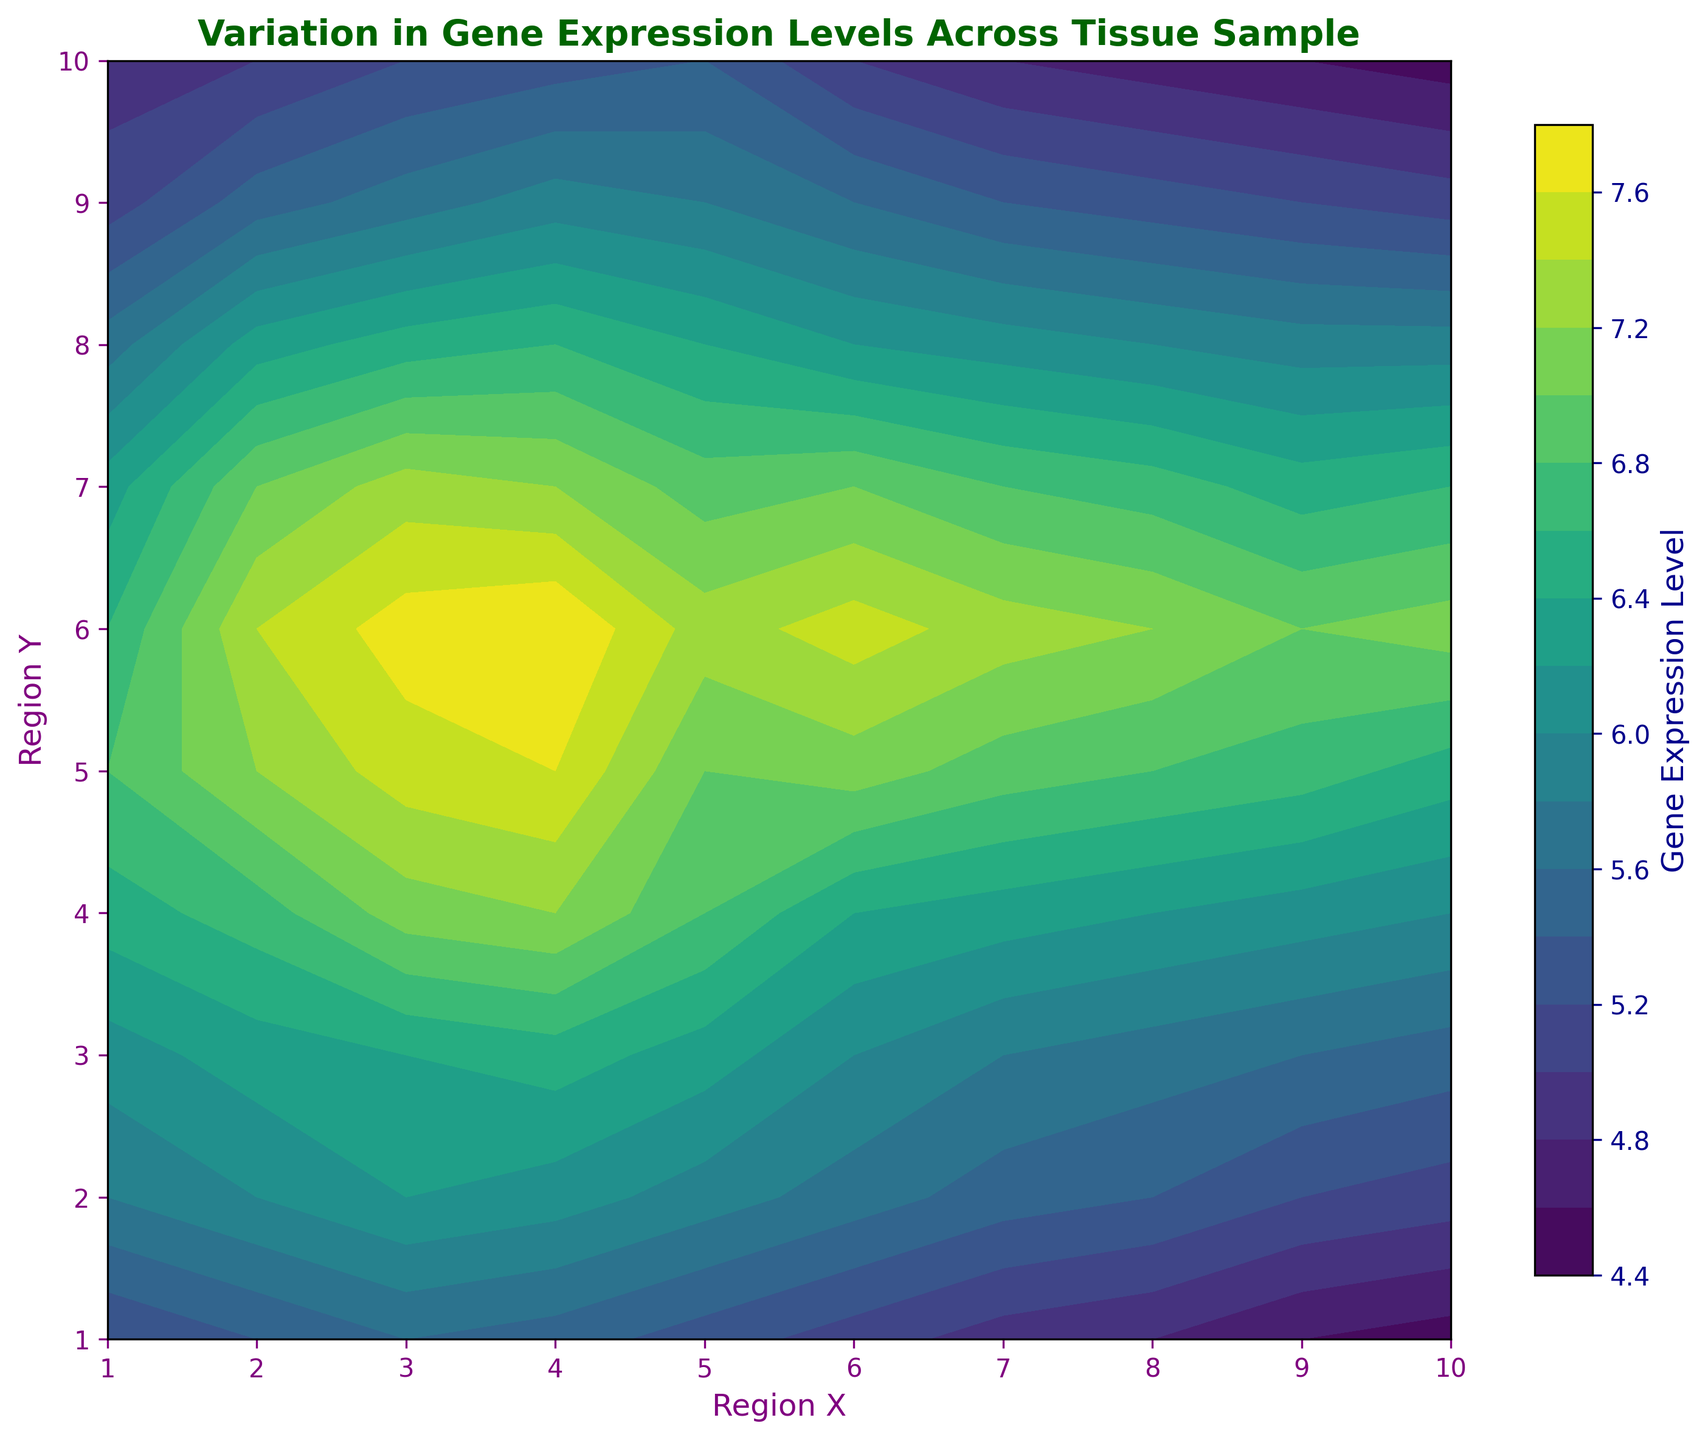What's the highest gene expression level in the tissue sample? Examine the color bar and locate the highest value represented. The highest level is observed as the deepest color presented in the contour plot, which aligns with approximately 7.8.
Answer: 7.8 In which regions do we observe the lowest values for gene expression? Identify the regions with the lightest colors on the plot. The lightest regions, along with reference to the color bar, indicate the lowest gene expression levels, which occur near (10,1) and (10,10).
Answer: (10,1) and (10,10) Which region has the highest variability in gene expression from top to bottom? Compare the vertical color transitions for each region. Region X=1 shows the highest color variation from top to bottom, indicating the most variability in gene expression from Y=1 to Y=10.
Answer: X=1 What is the range of gene expression levels in Region X=5? Identify the minimum and maximum values within X=5. Using color transitions and the color bar, the lowest value is approximately 5.3 and the highest value is around 7.3. Therefore, the range is 7.3 - 5.3 = 2.0
Answer: 2.0 Between Regions X=3 and X=7, which shows higher average gene expression? Visually compare the colors and their values from the color bar. Region X=3 has generally darker colors compared to X=7, suggesting higher overall gene expression. Specifically, X=3 ranges 5.2-7.7, while X=7 ranges 4.8-7.3.
Answer: X=3 How does gene expression change as you move horizontally from Region Y=3 to Y=10? Observe color transitions along horizontal lines. At Region X=1, the colors shift progressively to lighter shades from Region Y=3 to Y=10, reflecting decreasing gene expression levels.
Answer: Decreases What's the highest gene expression level between Regions X=2 and X=4? Look at the color intensity and match with the color bar. The maximum color intensity, thus gene expression level, in these regions is around 7.8.
Answer: 7.8 Which Region Y has a uniformly consistent gene expression level? Look for a horizontal line showing consistent color. Region Y=1 seems to be the most uniform, maintaining consistent shades across different X-values.
Answer: Y=1 How does gene expression in Region X=4 compare with X=8? Compare colors' intensity over these regions indicated by the color bar. Region X=4 generally shows darker colors (higher on the color bar) compared to X=8, indicating higher gene expression levels in X=4.
Answer: Higher in X=4 What is the median gene expression level in the entire tissue sample? Estimate median value using the color bar, noting mid-range colors. Means evaluating colors: central color spans between around 5.7 to 6.5, with the median approximately around 6.
Answer: 6 